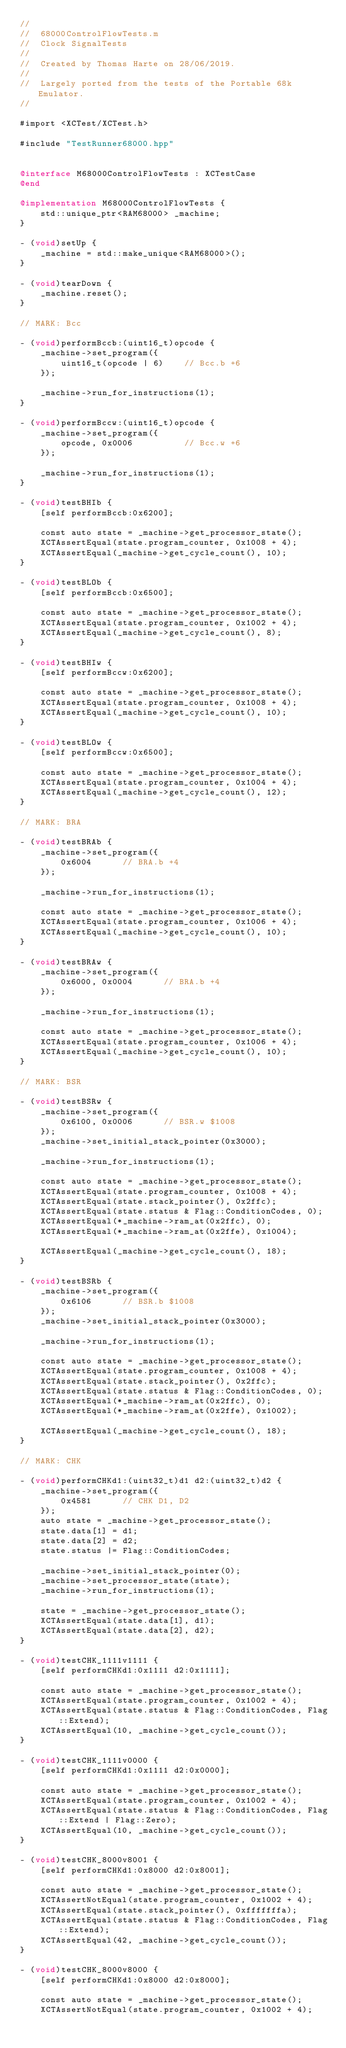Convert code to text. <code><loc_0><loc_0><loc_500><loc_500><_ObjectiveC_>//
//  68000ControlFlowTests.m
//  Clock SignalTests
//
//  Created by Thomas Harte on 28/06/2019.
//
//  Largely ported from the tests of the Portable 68k Emulator.
//

#import <XCTest/XCTest.h>

#include "TestRunner68000.hpp"


@interface M68000ControlFlowTests : XCTestCase
@end

@implementation M68000ControlFlowTests {
	std::unique_ptr<RAM68000> _machine;
}

- (void)setUp {
    _machine = std::make_unique<RAM68000>();
}

- (void)tearDown {
	_machine.reset();
}

// MARK: Bcc

- (void)performBccb:(uint16_t)opcode {
	_machine->set_program({
		uint16_t(opcode | 6)	// Bcc.b +6
	});

	_machine->run_for_instructions(1);
}

- (void)performBccw:(uint16_t)opcode {
	_machine->set_program({
		opcode, 0x0006			// Bcc.w +6
	});

	_machine->run_for_instructions(1);
}

- (void)testBHIb {
	[self performBccb:0x6200];

	const auto state = _machine->get_processor_state();
	XCTAssertEqual(state.program_counter, 0x1008 + 4);
	XCTAssertEqual(_machine->get_cycle_count(), 10);
}

- (void)testBLOb {
	[self performBccb:0x6500];

	const auto state = _machine->get_processor_state();
	XCTAssertEqual(state.program_counter, 0x1002 + 4);
	XCTAssertEqual(_machine->get_cycle_count(), 8);
}

- (void)testBHIw {
	[self performBccw:0x6200];

	const auto state = _machine->get_processor_state();
	XCTAssertEqual(state.program_counter, 0x1008 + 4);
	XCTAssertEqual(_machine->get_cycle_count(), 10);
}

- (void)testBLOw {
	[self performBccw:0x6500];

	const auto state = _machine->get_processor_state();
	XCTAssertEqual(state.program_counter, 0x1004 + 4);
	XCTAssertEqual(_machine->get_cycle_count(), 12);
}

// MARK: BRA

- (void)testBRAb {
	_machine->set_program({
		0x6004		// BRA.b +4
	});

	_machine->run_for_instructions(1);

	const auto state = _machine->get_processor_state();
	XCTAssertEqual(state.program_counter, 0x1006 + 4);
	XCTAssertEqual(_machine->get_cycle_count(), 10);
}

- (void)testBRAw {
	_machine->set_program({
		0x6000, 0x0004		// BRA.b +4
	});

	_machine->run_for_instructions(1);

	const auto state = _machine->get_processor_state();
	XCTAssertEqual(state.program_counter, 0x1006 + 4);
	XCTAssertEqual(_machine->get_cycle_count(), 10);
}

// MARK: BSR

- (void)testBSRw {
	_machine->set_program({
		0x6100, 0x0006		// BSR.w $1008
	});
	_machine->set_initial_stack_pointer(0x3000);

	_machine->run_for_instructions(1);

	const auto state = _machine->get_processor_state();
	XCTAssertEqual(state.program_counter, 0x1008 + 4);
	XCTAssertEqual(state.stack_pointer(), 0x2ffc);
	XCTAssertEqual(state.status & Flag::ConditionCodes, 0);
	XCTAssertEqual(*_machine->ram_at(0x2ffc), 0);
	XCTAssertEqual(*_machine->ram_at(0x2ffe), 0x1004);

	XCTAssertEqual(_machine->get_cycle_count(), 18);
}

- (void)testBSRb {
	_machine->set_program({
		0x6106		// BSR.b $1008
	});
	_machine->set_initial_stack_pointer(0x3000);

	_machine->run_for_instructions(1);

	const auto state = _machine->get_processor_state();
	XCTAssertEqual(state.program_counter, 0x1008 + 4);
	XCTAssertEqual(state.stack_pointer(), 0x2ffc);
	XCTAssertEqual(state.status & Flag::ConditionCodes, 0);
	XCTAssertEqual(*_machine->ram_at(0x2ffc), 0);
	XCTAssertEqual(*_machine->ram_at(0x2ffe), 0x1002);

	XCTAssertEqual(_machine->get_cycle_count(), 18);
}

// MARK: CHK

- (void)performCHKd1:(uint32_t)d1 d2:(uint32_t)d2 {
	_machine->set_program({
		0x4581		// CHK D1, D2
	});
	auto state = _machine->get_processor_state();
	state.data[1] = d1;
	state.data[2] = d2;
	state.status |= Flag::ConditionCodes;

	_machine->set_initial_stack_pointer(0);
	_machine->set_processor_state(state);
	_machine->run_for_instructions(1);

	state = _machine->get_processor_state();
	XCTAssertEqual(state.data[1], d1);
	XCTAssertEqual(state.data[2], d2);
}

- (void)testCHK_1111v1111 {
	[self performCHKd1:0x1111 d2:0x1111];

	const auto state = _machine->get_processor_state();
	XCTAssertEqual(state.program_counter, 0x1002 + 4);
	XCTAssertEqual(state.status & Flag::ConditionCodes, Flag::Extend);
	XCTAssertEqual(10, _machine->get_cycle_count());
}

- (void)testCHK_1111v0000 {
	[self performCHKd1:0x1111 d2:0x0000];

	const auto state = _machine->get_processor_state();
	XCTAssertEqual(state.program_counter, 0x1002 + 4);
	XCTAssertEqual(state.status & Flag::ConditionCodes, Flag::Extend | Flag::Zero);
	XCTAssertEqual(10, _machine->get_cycle_count());
}

- (void)testCHK_8000v8001 {
	[self performCHKd1:0x8000 d2:0x8001];

	const auto state = _machine->get_processor_state();
	XCTAssertNotEqual(state.program_counter, 0x1002 + 4);
	XCTAssertEqual(state.stack_pointer(), 0xfffffffa);
	XCTAssertEqual(state.status & Flag::ConditionCodes, Flag::Extend);
	XCTAssertEqual(42, _machine->get_cycle_count());
}

- (void)testCHK_8000v8000 {
	[self performCHKd1:0x8000 d2:0x8000];

	const auto state = _machine->get_processor_state();
	XCTAssertNotEqual(state.program_counter, 0x1002 + 4);</code> 